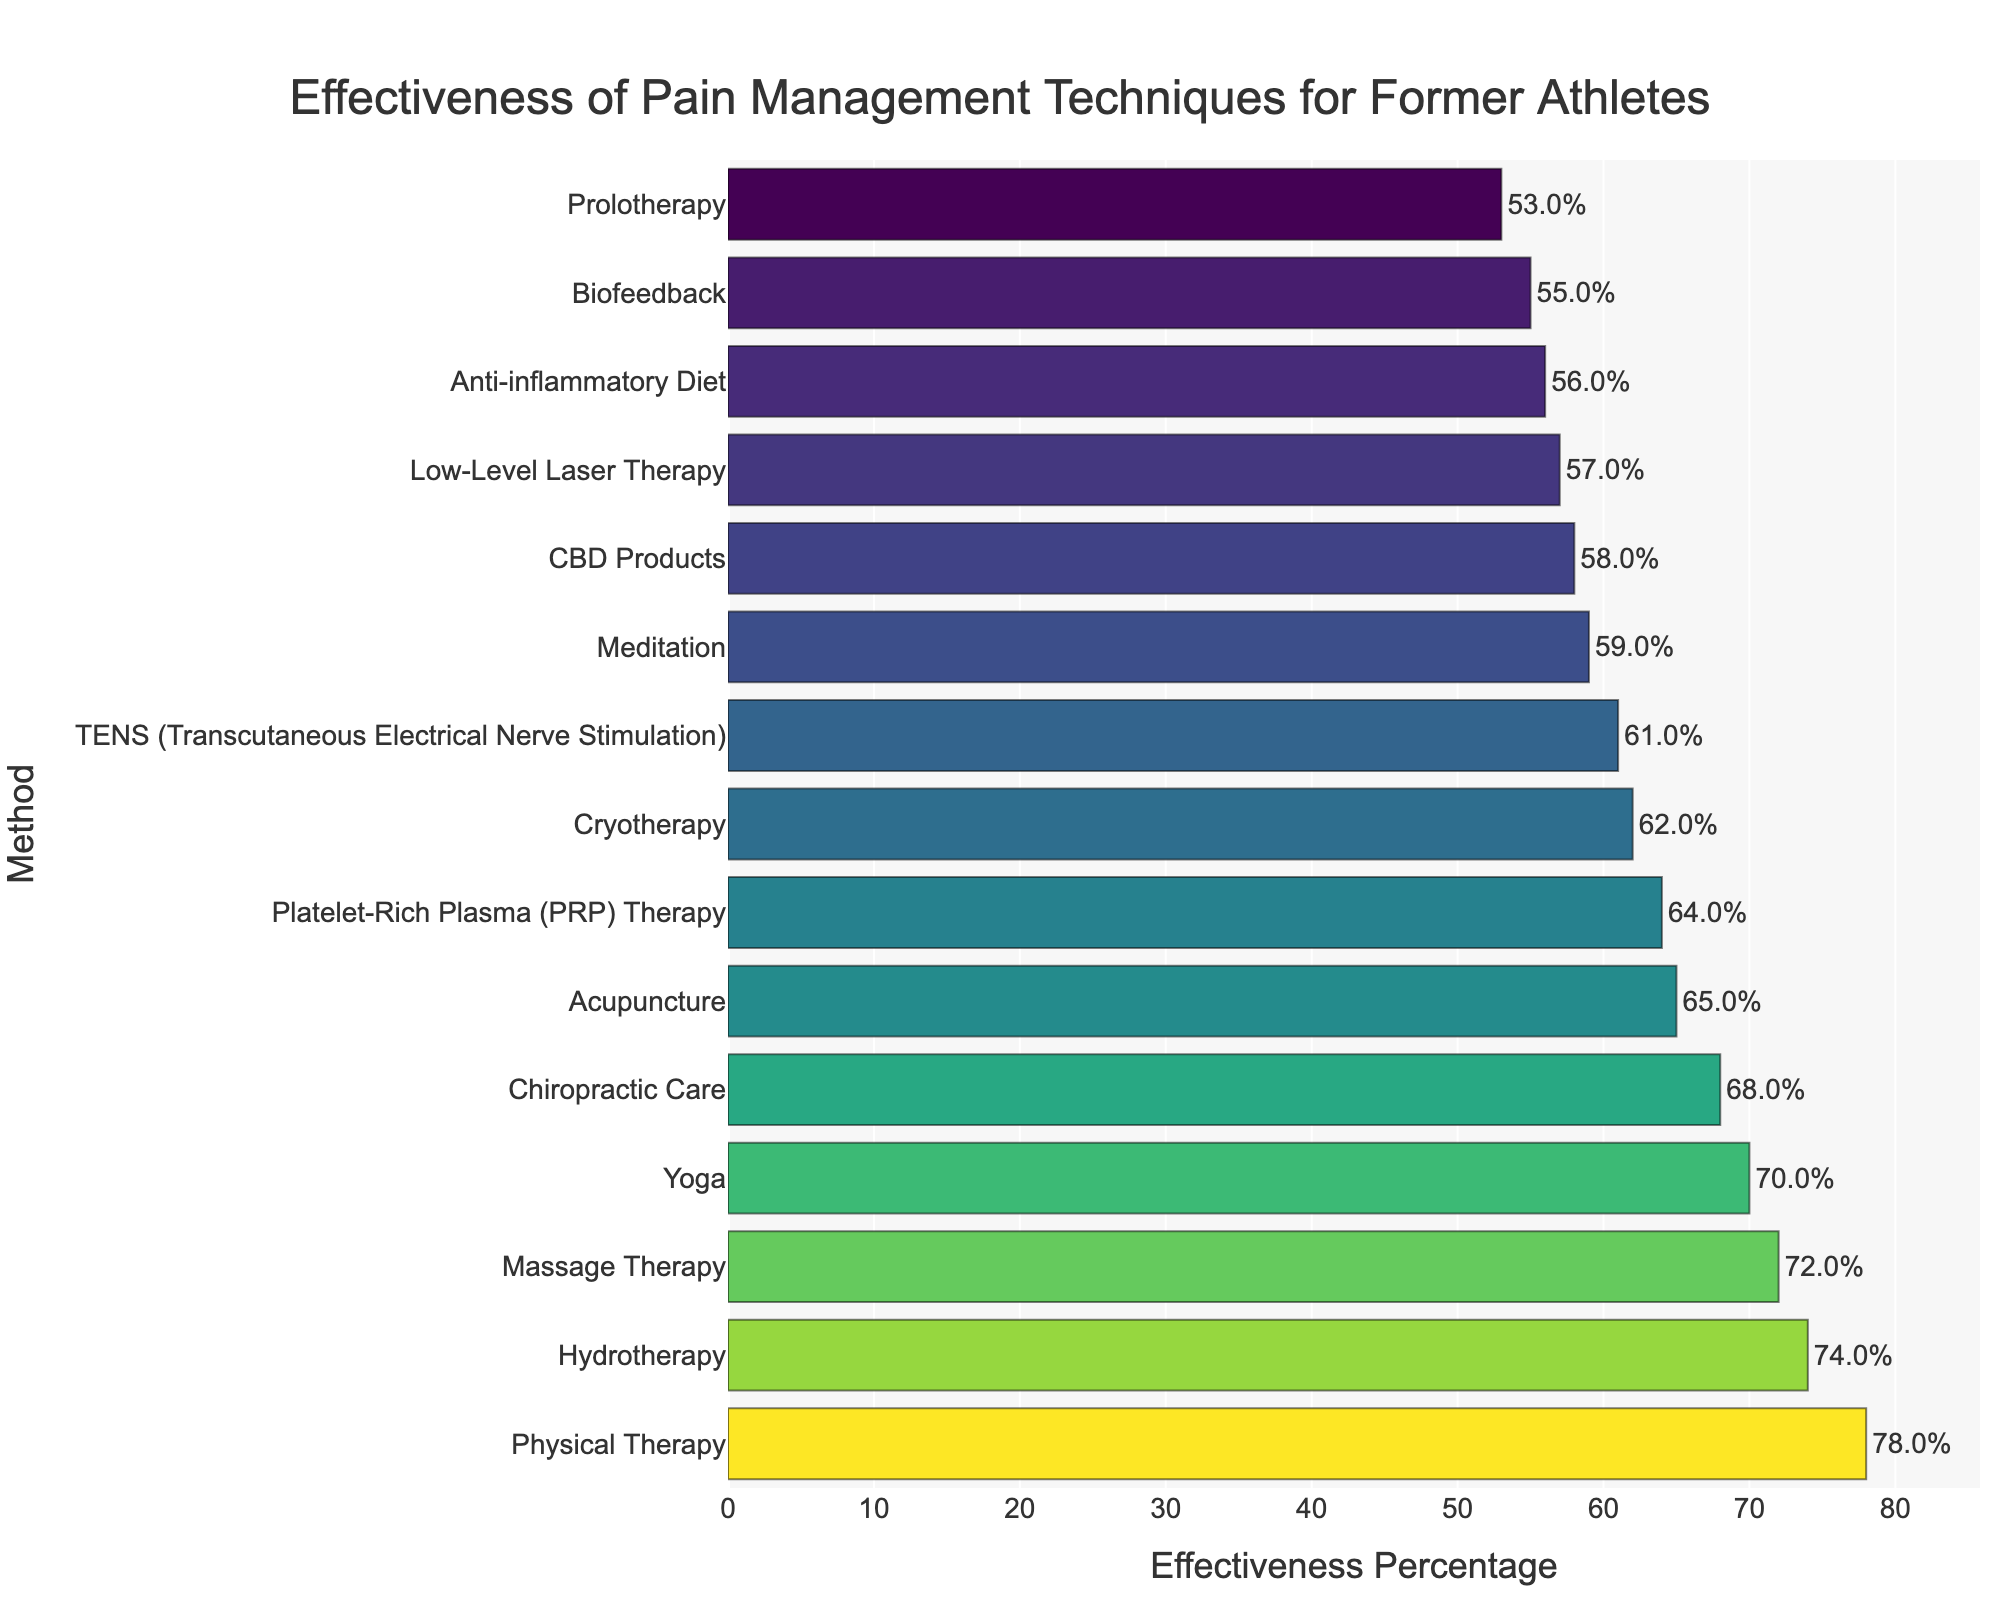Which method is shown to be the most effective? The bar chart indicates that the lengthiest bar represents the most effective method. Physical Therapy has the highest effectiveness percentage at 78%.
Answer: Physical Therapy Which method has a higher effectiveness: Acupuncture or CBD Products? By comparing the heights of the bars for Acupuncture and CBD Products, it shows that Acupuncture has an effectiveness percentage of 65%, while CBD Products has 58%.
Answer: Acupuncture What is the difference in effectiveness between Chiropractic Care and Cryotherapy? The effectiveness percentage for Chiropractic Care is 68%, and for Cryotherapy, it is 62%. Subtracting these gives 68% - 62% = 6%.
Answer: 6% What are the three least effective methods? The three shortest bars in the chart represent the least effective methods, which are Prolotherapy, Anti-inflammatory Diet, and Biofeedback with effectiveness percentages of 53%, 56%, and 55%, respectively.
Answer: Prolotherapy, Anti-inflammatory Diet, Biofeedback How much higher is the effectiveness percentage of Hydrotherapy than that of Meditation? The effectiveness percentage for Hydrotherapy is 74%, and for Meditation, it is 59%. The difference is 74% - 59% = 15%.
Answer: 15% Which methods have an effectiveness percentage between 60% and 70%? The methods falling within the 60% to 70% effectiveness range include Acupuncture (65%), Chiropractic Care (68%), TENS (61%), Cryotherapy (62%), Meditation (59%), and Platelet-Rich Plasma (PRP) Therapy (64%).
Answer: Acupuncture, Chiropractic Care, TENS, Cryotherapy, Meditation, PRP Therapy What is the total effectiveness percentage for Massage Therapy and Yoga combined? Massage Therapy has an effectiveness percentage of 72%, and Yoga has 70%. Adding these together yields 72% + 70% = 142%.
Answer: 142% How many methods have effectiveness percentages above 70%? Examining the bars with effectiveness percentages over 70% identifies three methods: Physical Therapy (78%), Massage Therapy (72%), and Hydrotherapy (74%).
Answer: 3 Which method is the closest in effectiveness to Platelet-Rich Plasma (PRP) Therapy? Platelet-Rich Plasma (PRP) Therapy has an effectiveness percentage of 64%. The closest method by comparison is Acupuncture, which has an effectiveness percentage of 65%.
Answer: Acupuncture What is the median effectiveness percentage of the methods? To find the median, list all effectiveness percentages in ascending order and identify the middle value. The ordered percentages are 53%, 55%, 56%, 57%, 58%, 59%, 61%, 62%, 64%, 65%, 68%, 70%, 72%, 74%, 78%. The median is the 8th value, which is 62%.
Answer: 62% 